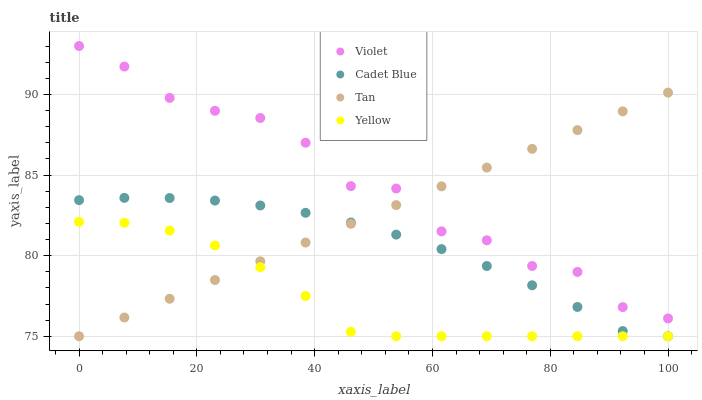Does Yellow have the minimum area under the curve?
Answer yes or no. Yes. Does Violet have the maximum area under the curve?
Answer yes or no. Yes. Does Cadet Blue have the minimum area under the curve?
Answer yes or no. No. Does Cadet Blue have the maximum area under the curve?
Answer yes or no. No. Is Tan the smoothest?
Answer yes or no. Yes. Is Violet the roughest?
Answer yes or no. Yes. Is Cadet Blue the smoothest?
Answer yes or no. No. Is Cadet Blue the roughest?
Answer yes or no. No. Does Tan have the lowest value?
Answer yes or no. Yes. Does Violet have the lowest value?
Answer yes or no. No. Does Violet have the highest value?
Answer yes or no. Yes. Does Cadet Blue have the highest value?
Answer yes or no. No. Is Yellow less than Violet?
Answer yes or no. Yes. Is Violet greater than Yellow?
Answer yes or no. Yes. Does Violet intersect Tan?
Answer yes or no. Yes. Is Violet less than Tan?
Answer yes or no. No. Is Violet greater than Tan?
Answer yes or no. No. Does Yellow intersect Violet?
Answer yes or no. No. 